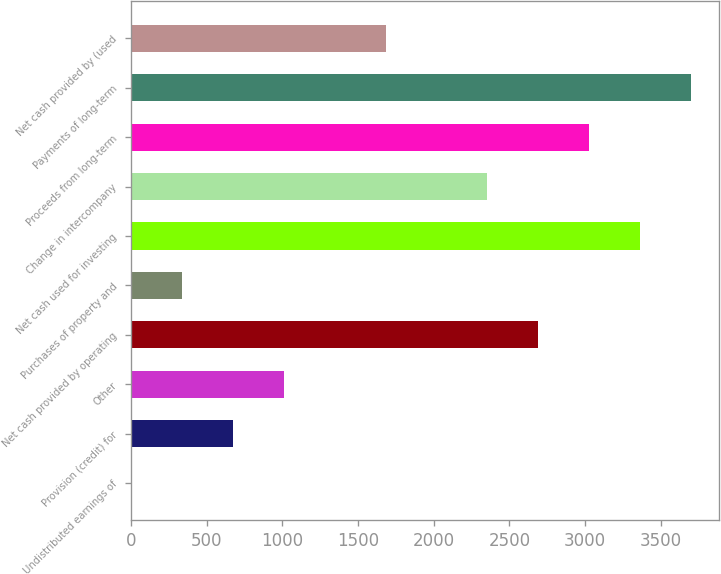Convert chart. <chart><loc_0><loc_0><loc_500><loc_500><bar_chart><fcel>Undistributed earnings of<fcel>Provision (credit) for<fcel>Other<fcel>Net cash provided by operating<fcel>Purchases of property and<fcel>Net cash used for investing<fcel>Change in intercompany<fcel>Proceeds from long-term<fcel>Payments of long-term<fcel>Net cash provided by (used<nl><fcel>0.9<fcel>673.56<fcel>1009.89<fcel>2691.54<fcel>337.23<fcel>3364.2<fcel>2355.21<fcel>3027.87<fcel>3700.53<fcel>1682.55<nl></chart> 